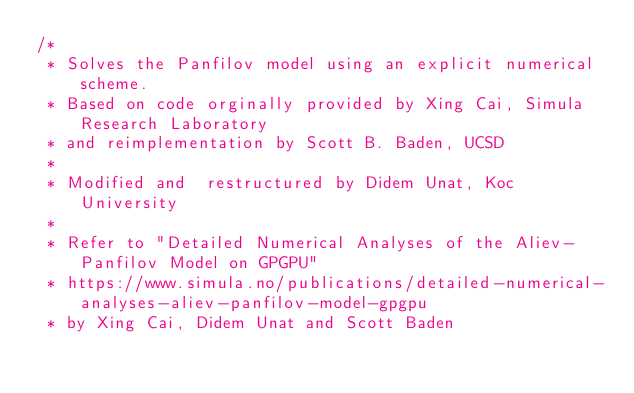<code> <loc_0><loc_0><loc_500><loc_500><_Cuda_>/* 
 * Solves the Panfilov model using an explicit numerical scheme.
 * Based on code orginally provided by Xing Cai, Simula Research Laboratory 
 * and reimplementation by Scott B. Baden, UCSD
 * 
 * Modified and  restructured by Didem Unat, Koc University
 *
 * Refer to "Detailed Numerical Analyses of the Aliev-Panfilov Model on GPGPU"
 * https://www.simula.no/publications/detailed-numerical-analyses-aliev-panfilov-model-gpgpu
 * by Xing Cai, Didem Unat and Scott Baden</code> 